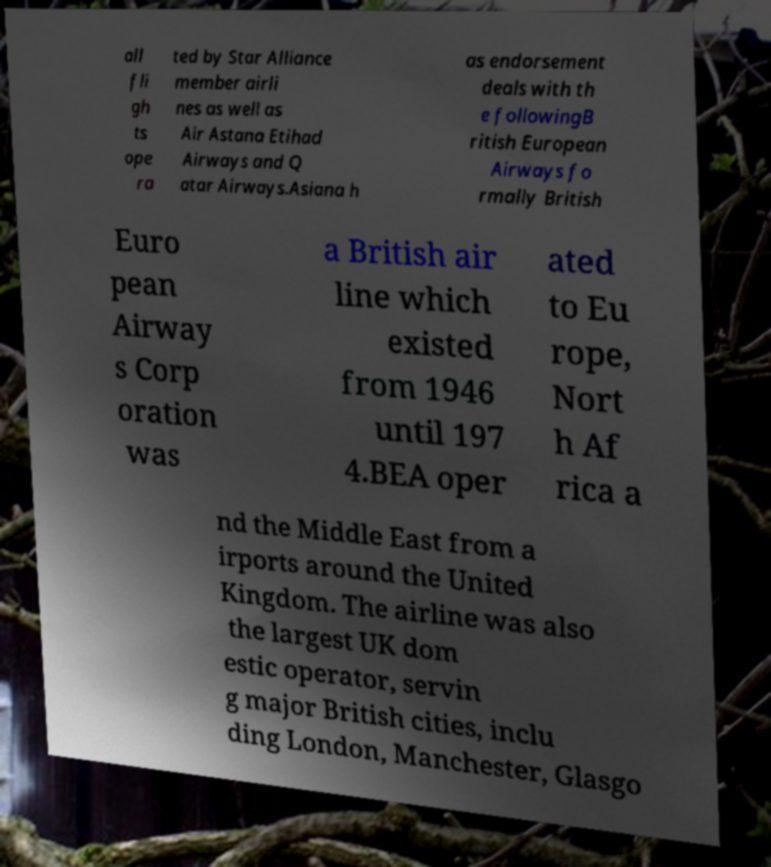Could you extract and type out the text from this image? all fli gh ts ope ra ted by Star Alliance member airli nes as well as Air Astana Etihad Airways and Q atar Airways.Asiana h as endorsement deals with th e followingB ritish European Airways fo rmally British Euro pean Airway s Corp oration was a British air line which existed from 1946 until 197 4.BEA oper ated to Eu rope, Nort h Af rica a nd the Middle East from a irports around the United Kingdom. The airline was also the largest UK dom estic operator, servin g major British cities, inclu ding London, Manchester, Glasgo 